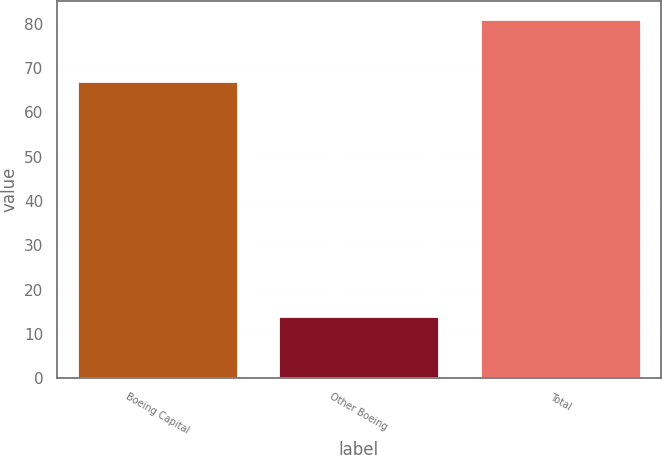<chart> <loc_0><loc_0><loc_500><loc_500><bar_chart><fcel>Boeing Capital<fcel>Other Boeing<fcel>Total<nl><fcel>67<fcel>14<fcel>81<nl></chart> 